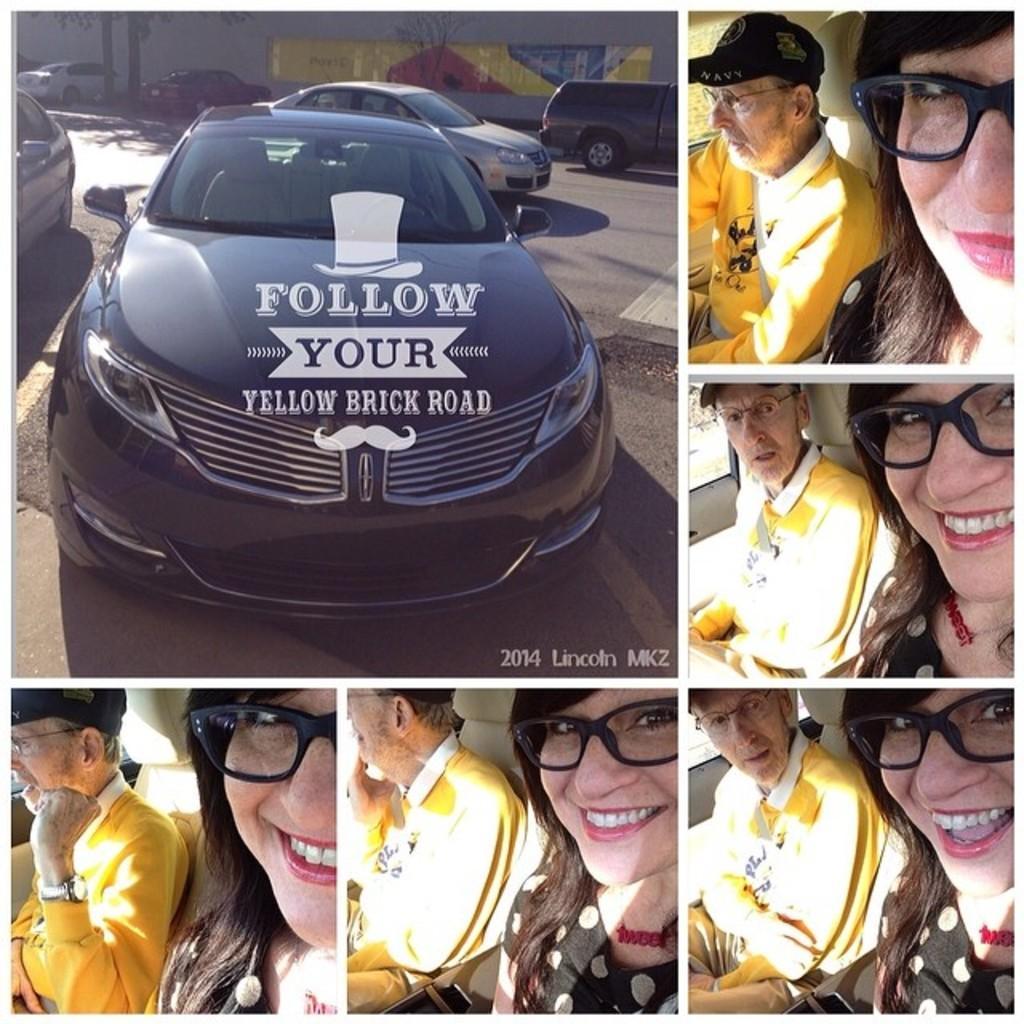Please provide a concise description of this image. It is a collage edited image. There are vehicles,a old man and a woman in this picture. 